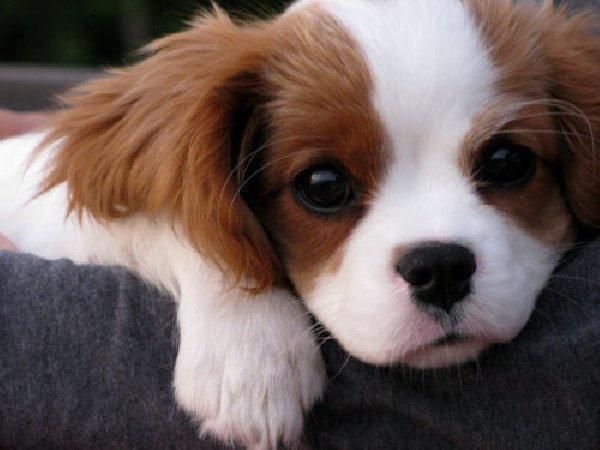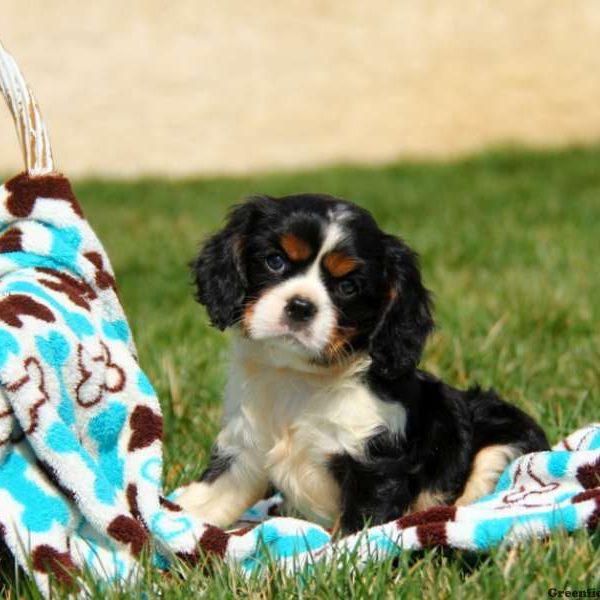The first image is the image on the left, the second image is the image on the right. Evaluate the accuracy of this statement regarding the images: "There are exactly two animals in the image on the left.". Is it true? Answer yes or no. No. 